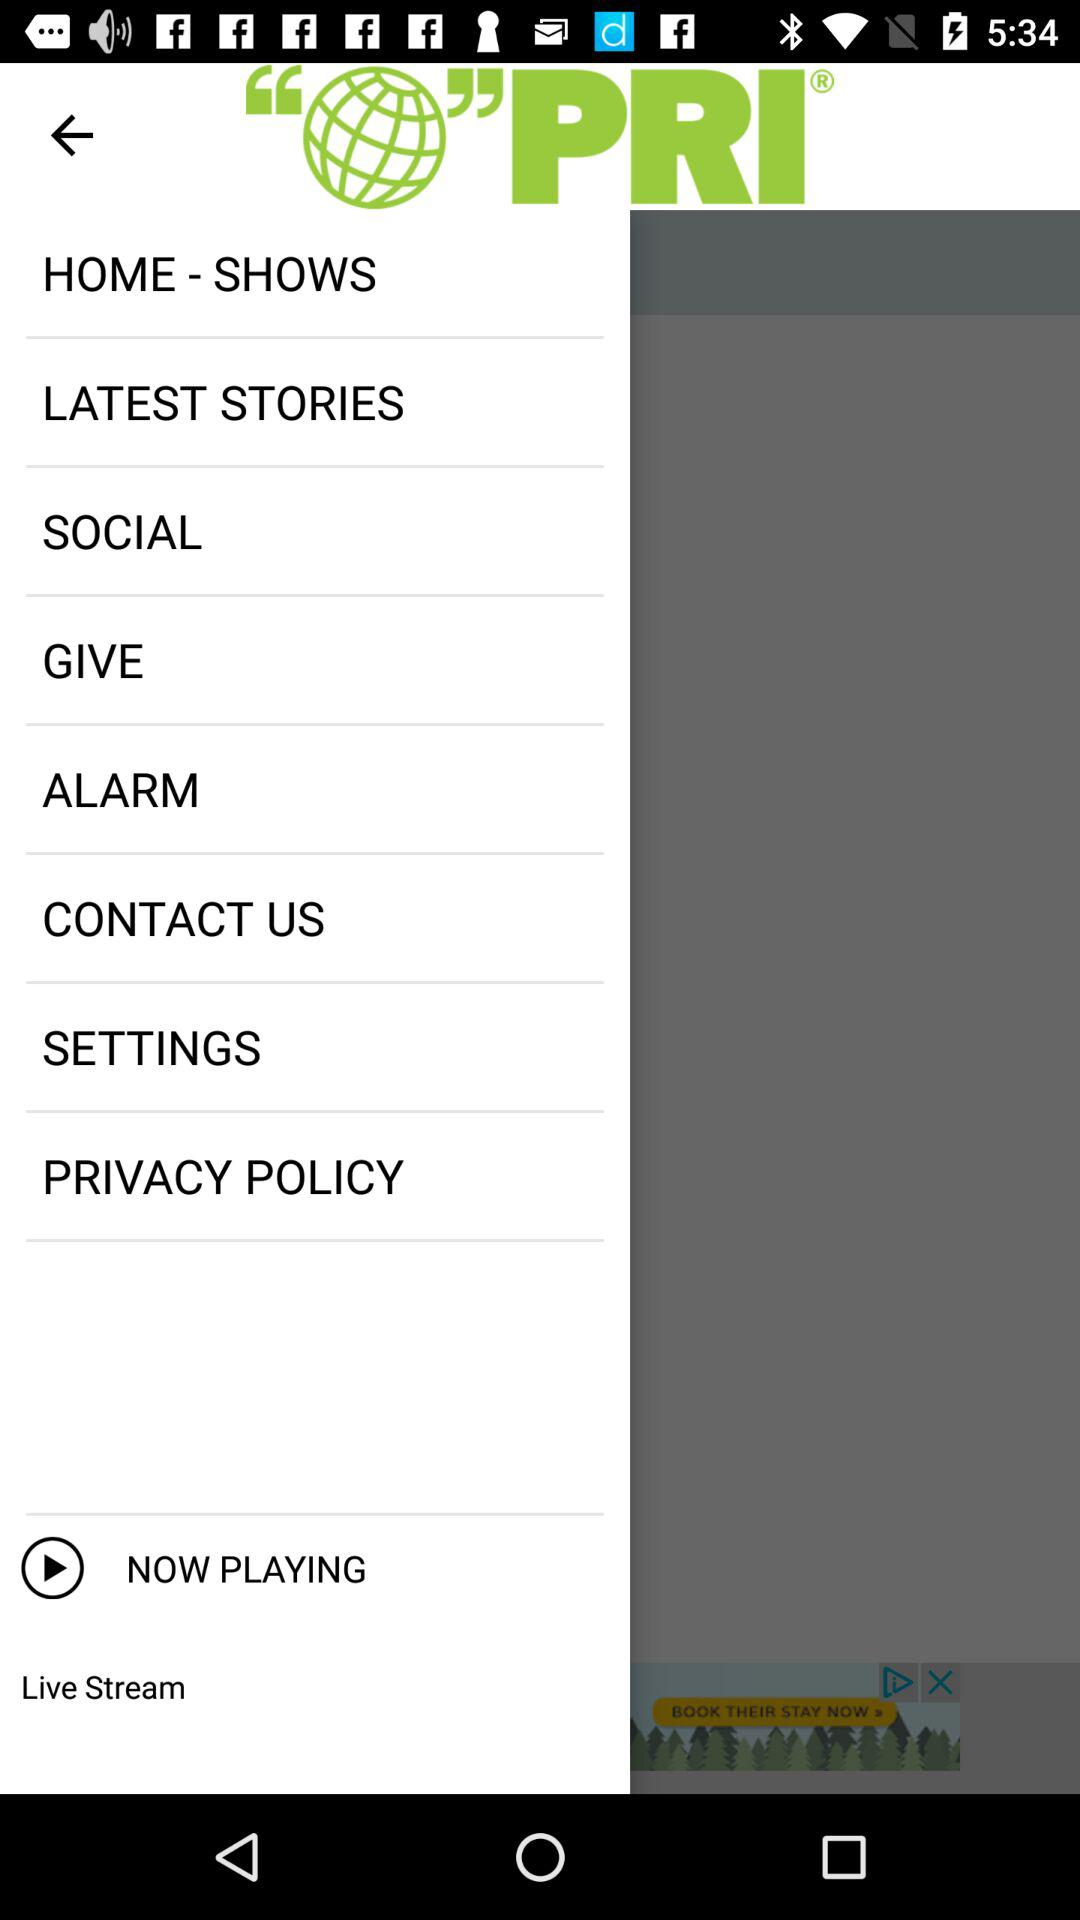What is the name of the application? The name of the application is "PRI". 